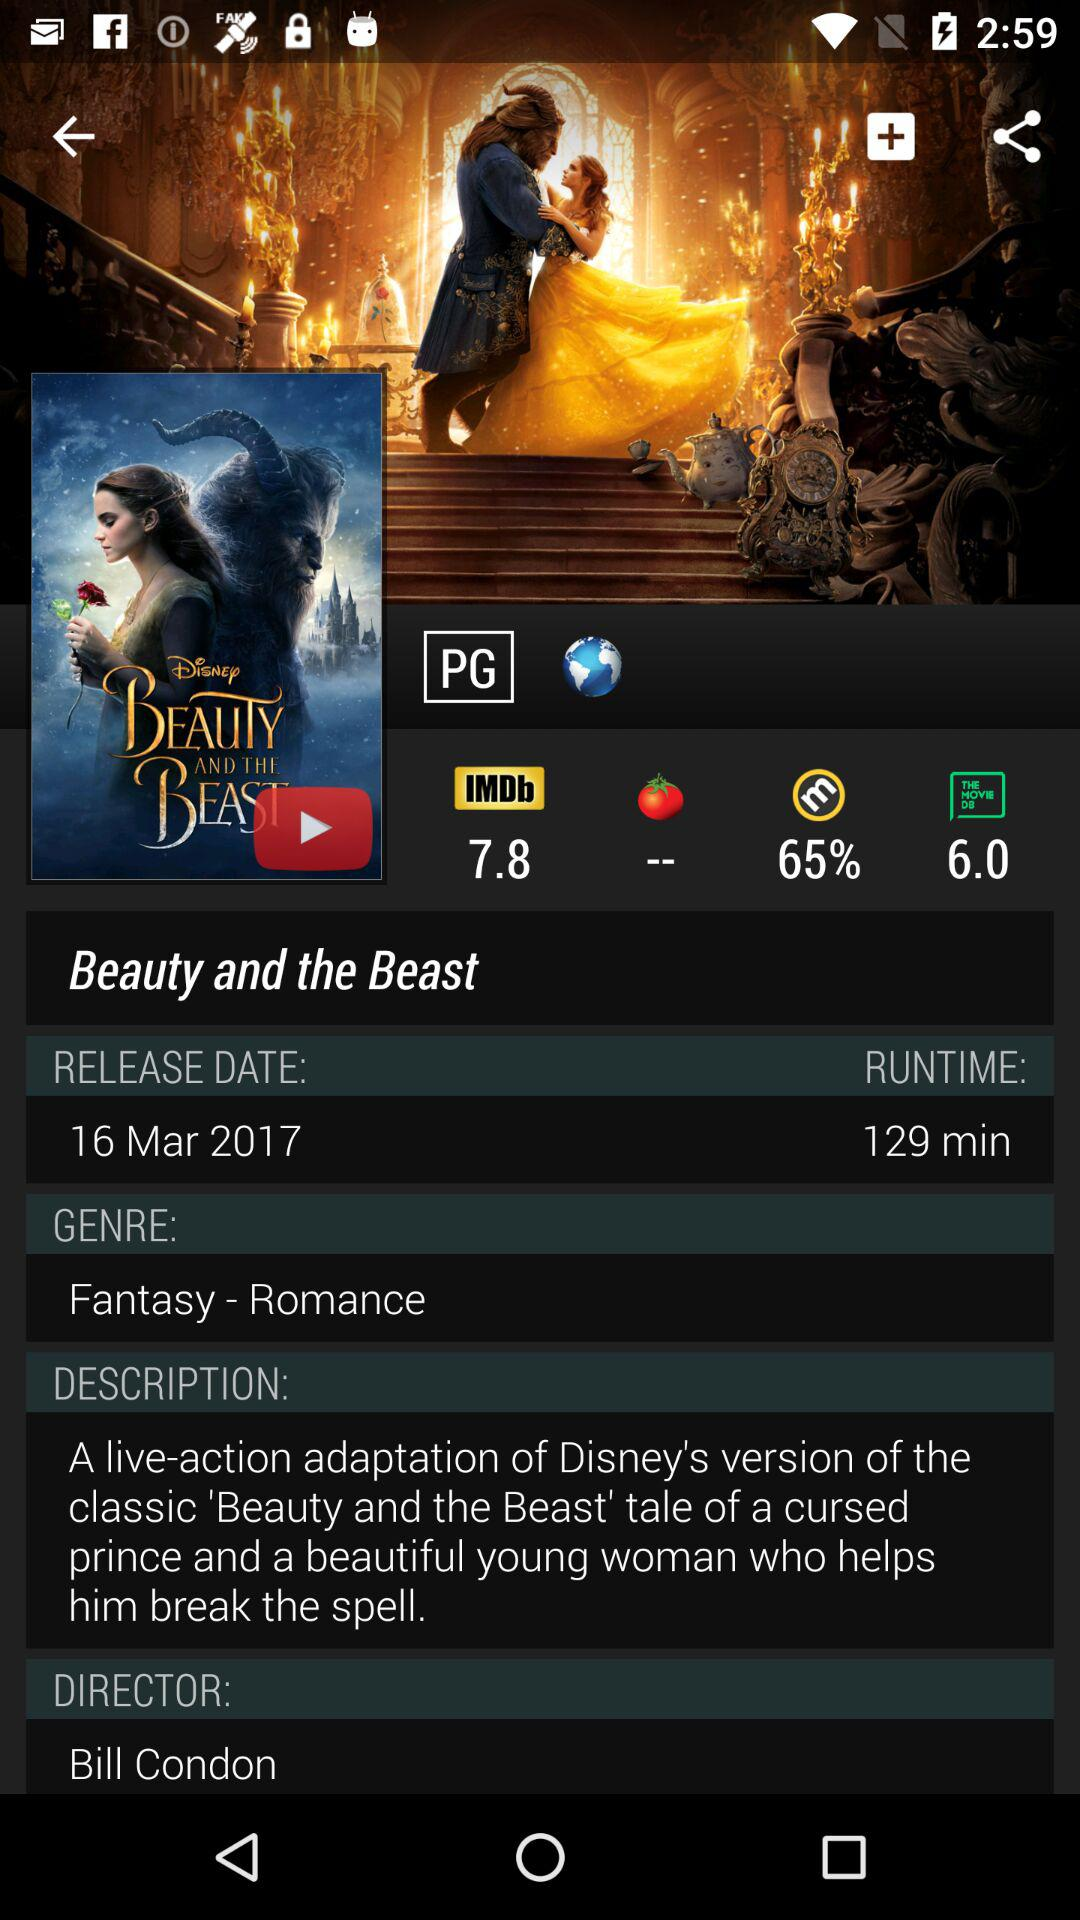What's the name of the movie? The name of the movie is Beauty and the Beast. 